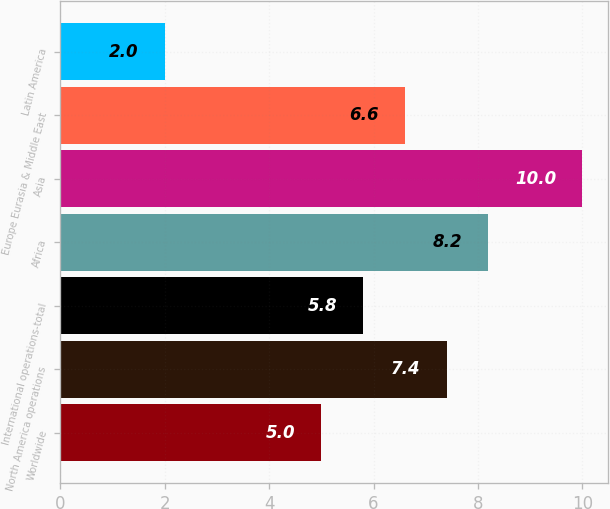Convert chart. <chart><loc_0><loc_0><loc_500><loc_500><bar_chart><fcel>Worldwide<fcel>North America operations<fcel>International operations-total<fcel>Africa<fcel>Asia<fcel>Europe Eurasia & Middle East<fcel>Latin America<nl><fcel>5<fcel>7.4<fcel>5.8<fcel>8.2<fcel>10<fcel>6.6<fcel>2<nl></chart> 